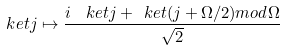Convert formula to latex. <formula><loc_0><loc_0><loc_500><loc_500>\ k e t { j } \mapsto \frac { i \ \ k e t { j } + \ k e t { ( j + \Omega / 2 ) { m o d } \Omega } } { \sqrt { 2 } }</formula> 